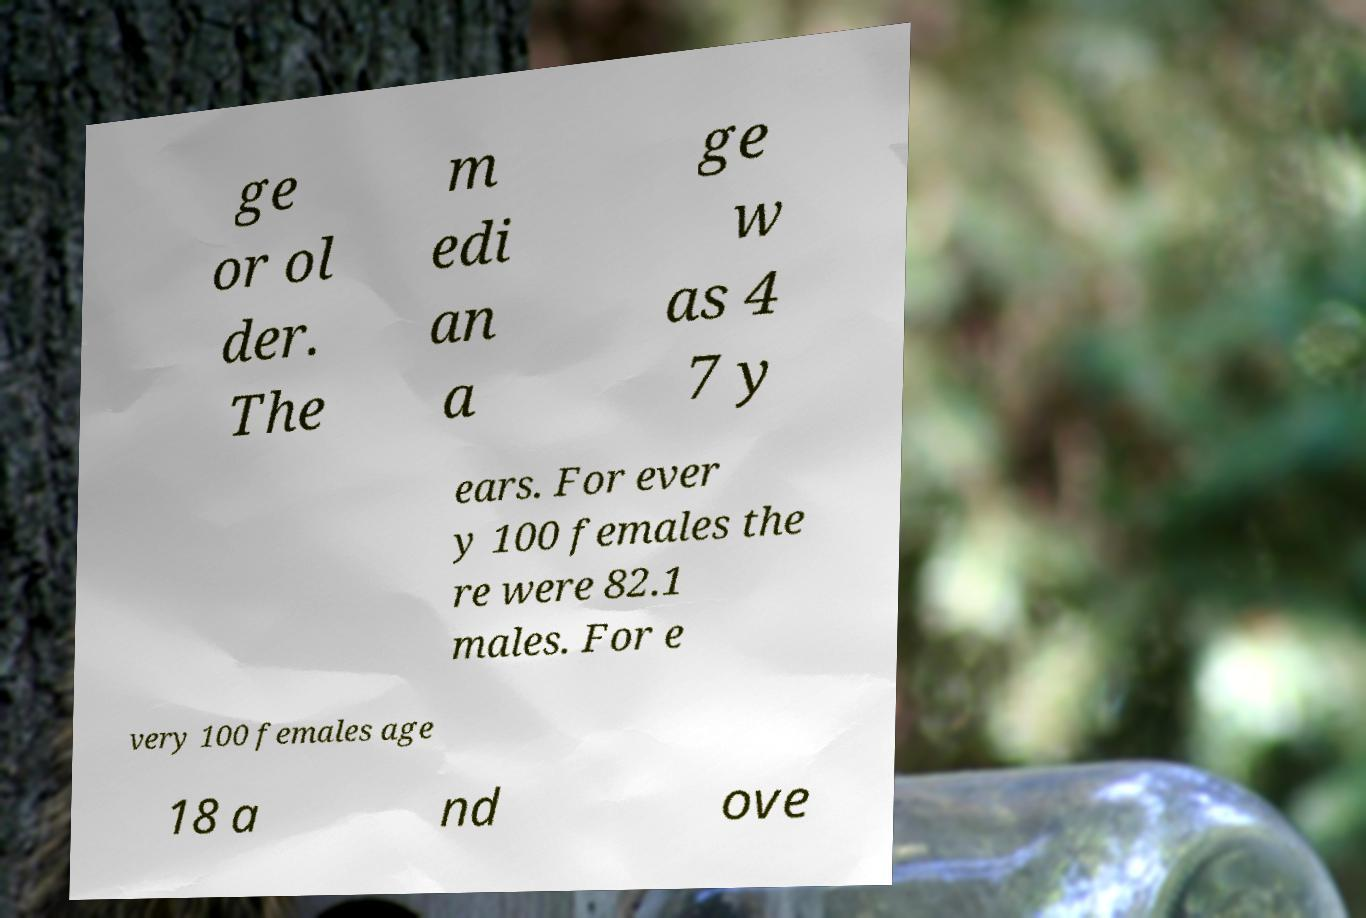Could you extract and type out the text from this image? ge or ol der. The m edi an a ge w as 4 7 y ears. For ever y 100 females the re were 82.1 males. For e very 100 females age 18 a nd ove 